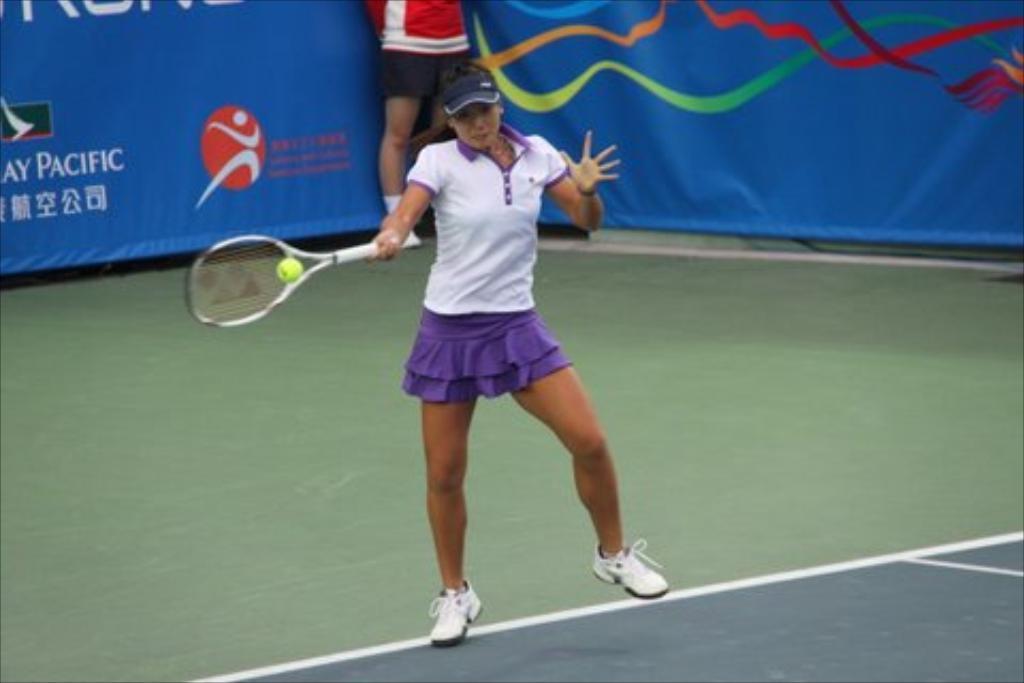Could you give a brief overview of what you see in this image? The photo is taken inside a ground. A lady wearing white t-shirt and purple skirt is hitting the ball by a racket. Behind her a person is standing. In the background there is a blue banner. 